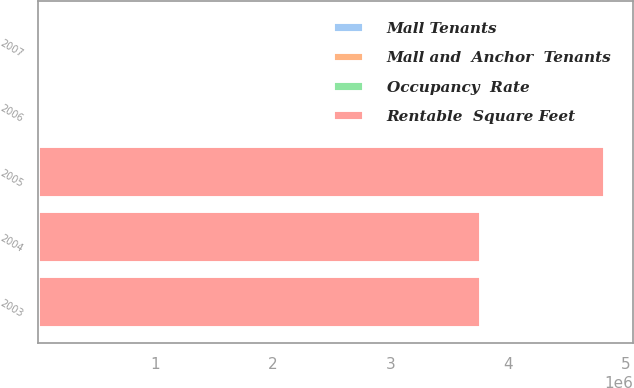Convert chart to OTSL. <chart><loc_0><loc_0><loc_500><loc_500><stacked_bar_chart><ecel><fcel>2007<fcel>2006<fcel>2005<fcel>2004<fcel>2003<nl><fcel>Rentable  Square Feet<fcel>33.995<fcel>33.995<fcel>4.817e+06<fcel>3.766e+06<fcel>3.766e+06<nl><fcel>Occupancy  Rate<fcel>96.1<fcel>93.4<fcel>96.2<fcel>93.1<fcel>94.1<nl><fcel>Mall and  Anchor  Tenants<fcel>34.94<fcel>32.64<fcel>31.83<fcel>33.05<fcel>31.08<nl><fcel>Mall Tenants<fcel>19.11<fcel>18.12<fcel>18.24<fcel>17.32<fcel>16.41<nl></chart> 